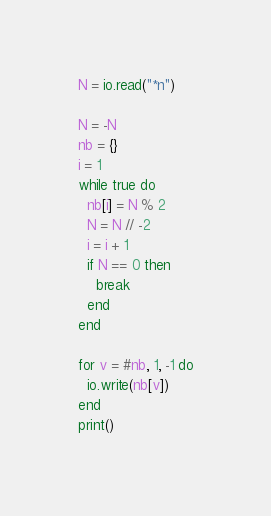<code> <loc_0><loc_0><loc_500><loc_500><_Lua_>N = io.read("*n")

N = -N
nb = {}
i = 1
while true do
  nb[i] = N % 2
  N = N // -2
  i = i + 1
  if N == 0 then
    break
  end
end

for v = #nb, 1, -1 do
  io.write(nb[v])
end
print()
</code> 